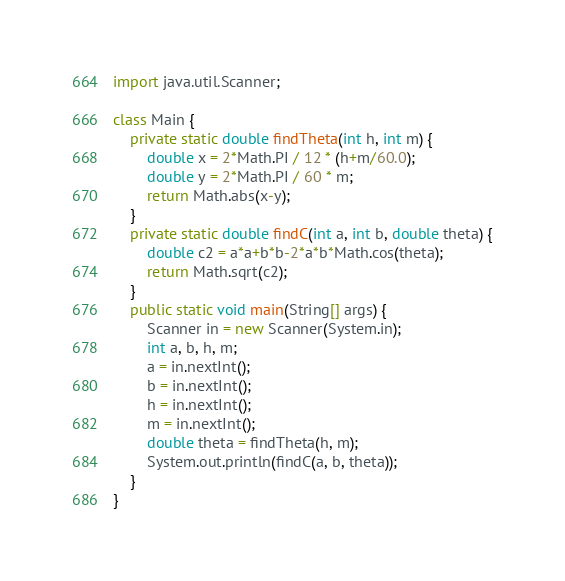<code> <loc_0><loc_0><loc_500><loc_500><_Java_>import java.util.Scanner;

class Main {
	private static double findTheta(int h, int m) {
    	double x = 2*Math.PI / 12 * (h+m/60.0);
		double y = 2*Math.PI / 60 * m;
      	return Math.abs(x-y);
    }
  	private static double findC(int a, int b, double theta) {
    	double c2 = a*a+b*b-2*a*b*Math.cos(theta);
      	return Math.sqrt(c2);
    }
  	public static void main(String[] args) {
    	Scanner in = new Scanner(System.in);
      	int a, b, h, m;
      	a = in.nextInt();
      	b = in.nextInt();
      	h = in.nextInt();
      	m = in.nextInt();
      	double theta = findTheta(h, m);
      	System.out.println(findC(a, b, theta));
    }
}</code> 